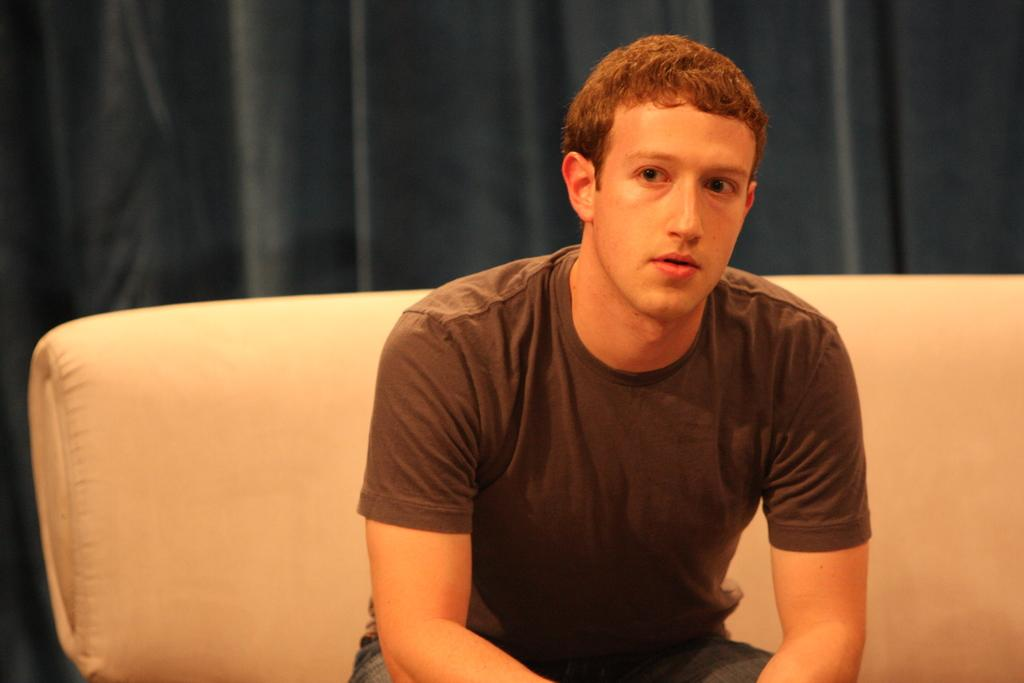What is the person in the image doing? The person is sitting on a couch in the image. What can be seen in the background of the image? There is a curtain in the background of the image. What type of flock is visible in the image? There is no flock present in the image; it features a person sitting on a couch and a curtain in the background. 